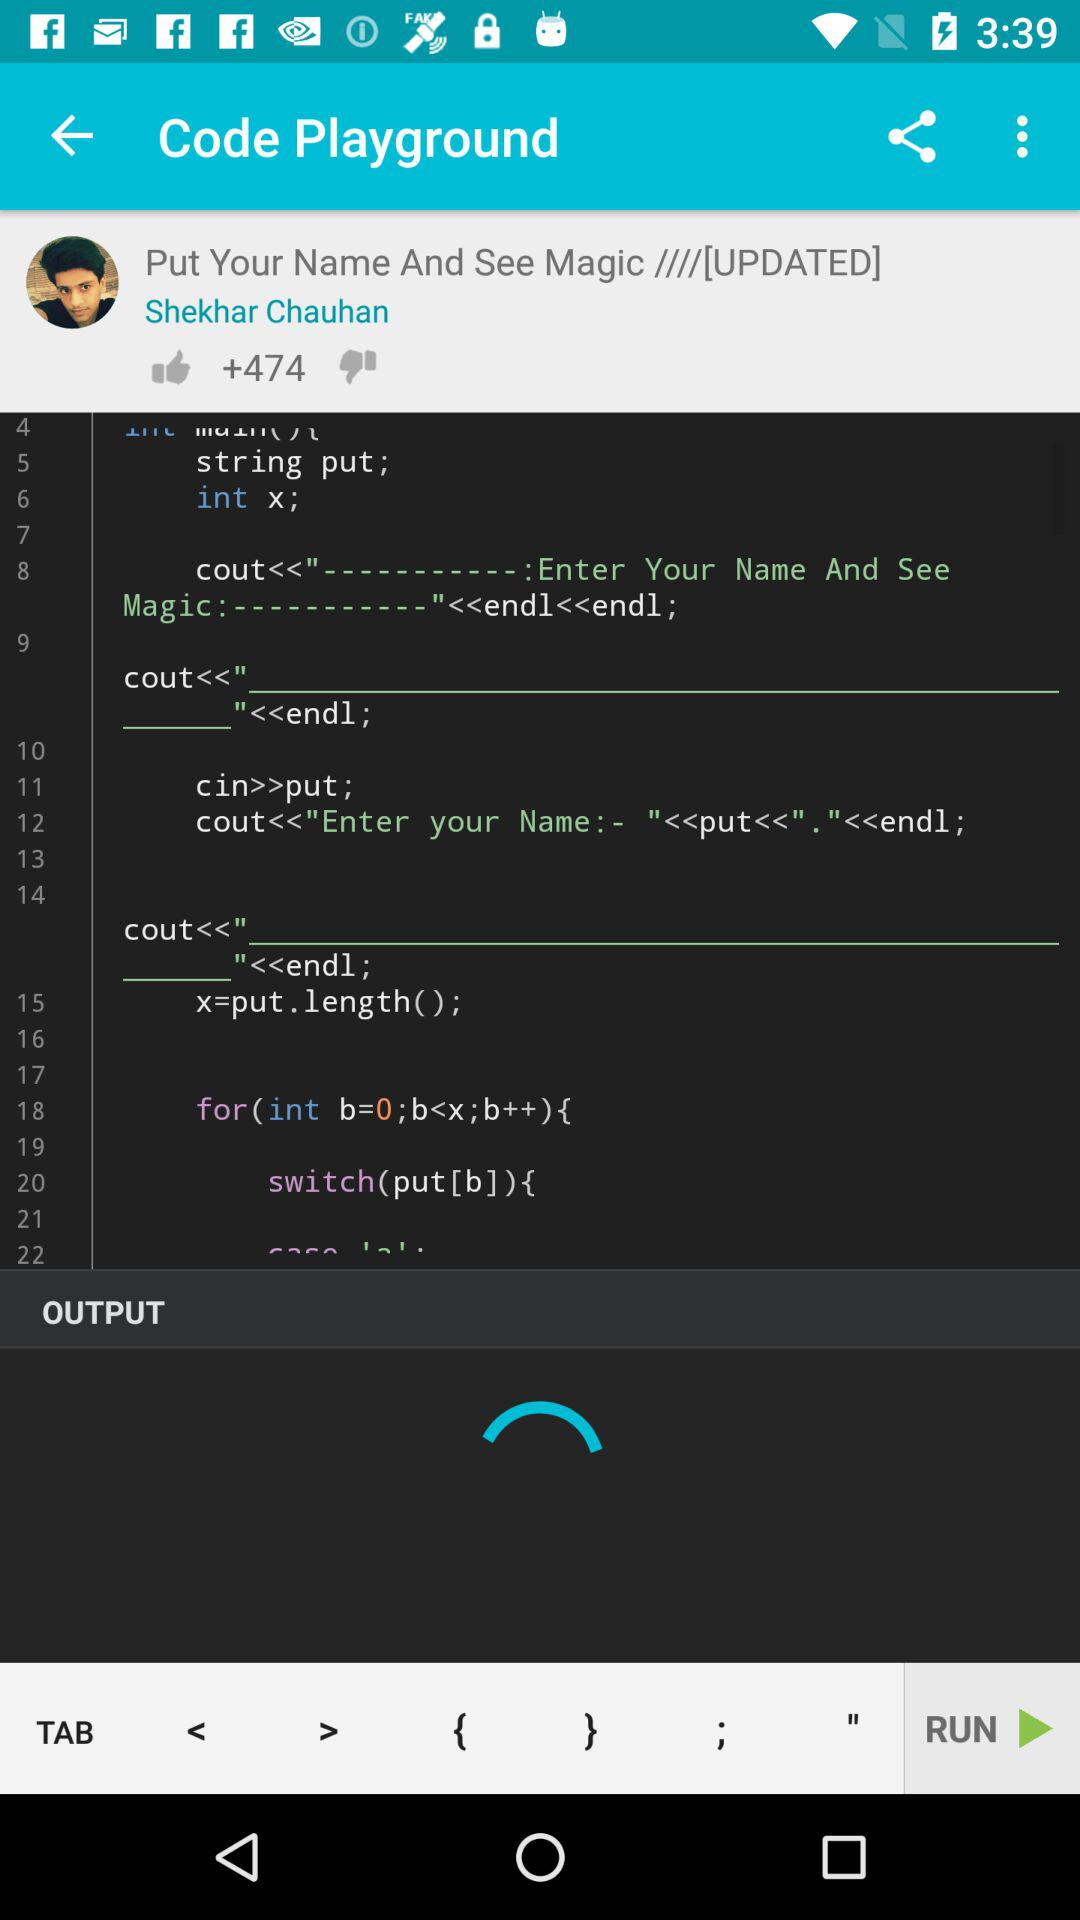How many likes did Shekhar Chauhan's post get? The post got more than 474 likes. 